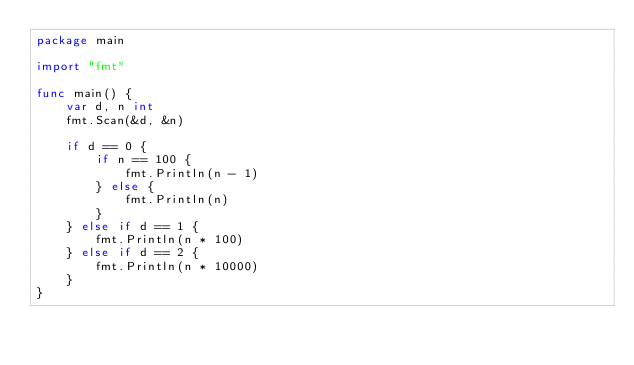Convert code to text. <code><loc_0><loc_0><loc_500><loc_500><_Go_>package main

import "fmt"

func main() {
	var d, n int
	fmt.Scan(&d, &n)

	if d == 0 {
		if n == 100 {
			fmt.Println(n - 1)
		} else {
			fmt.Println(n)
		}
	} else if d == 1 {
		fmt.Println(n * 100)
	} else if d == 2 {
		fmt.Println(n * 10000)
	}
}
</code> 